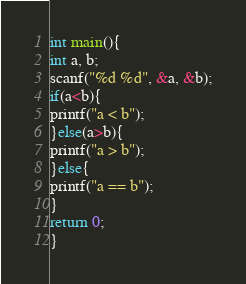Convert code to text. <code><loc_0><loc_0><loc_500><loc_500><_C_>int main(){
int a, b;
scanf("%d %d", &a, &b);
if(a<b){
printf("a < b");
}else(a>b){
printf("a > b");
}else{
printf("a == b");
}
return 0;
}</code> 